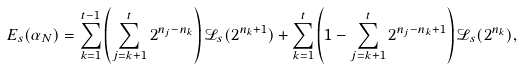Convert formula to latex. <formula><loc_0><loc_0><loc_500><loc_500>E _ { s } ( \alpha _ { N } ) = \sum _ { k = 1 } ^ { t - 1 } \left ( \sum _ { j = k + 1 } ^ { t } 2 ^ { n _ { j } - n _ { k } } \right ) \mathcal { L } _ { s } ( 2 ^ { n _ { k } + 1 } ) + \sum _ { k = 1 } ^ { t } \left ( 1 - \sum _ { j = k + 1 } ^ { t } 2 ^ { n _ { j } - n _ { k } + 1 } \right ) \mathcal { L } _ { s } ( 2 ^ { n _ { k } } ) ,</formula> 